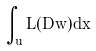Convert formula to latex. <formula><loc_0><loc_0><loc_500><loc_500>\int _ { u } L ( D w ) d x</formula> 